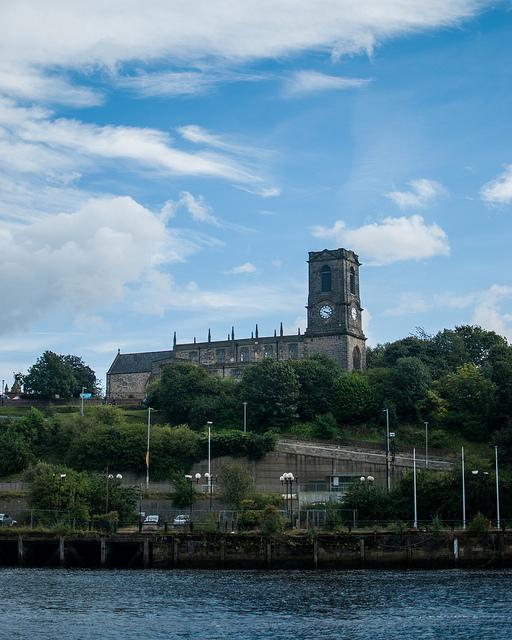What's on the other side of the trees?
Write a very short answer. Building. What color is the roof of the building?
Keep it brief. Brown. What is on the top of the hill?
Be succinct. Church. Is that a castle in the background?
Write a very short answer. Yes. What is the name of this landmark?
Keep it brief. Castle. How much of the picture does the water take up?
Quick response, please. 1/6. What is the building in the background?
Be succinct. Church. How many steeples are there?
Short answer required. 1. Are there boats on the water?
Concise answer only. No. How many cars are parked along the water?
Concise answer only. 3. What time is it?
Quick response, please. 2:20. How many buildings are there?
Concise answer only. 1. 